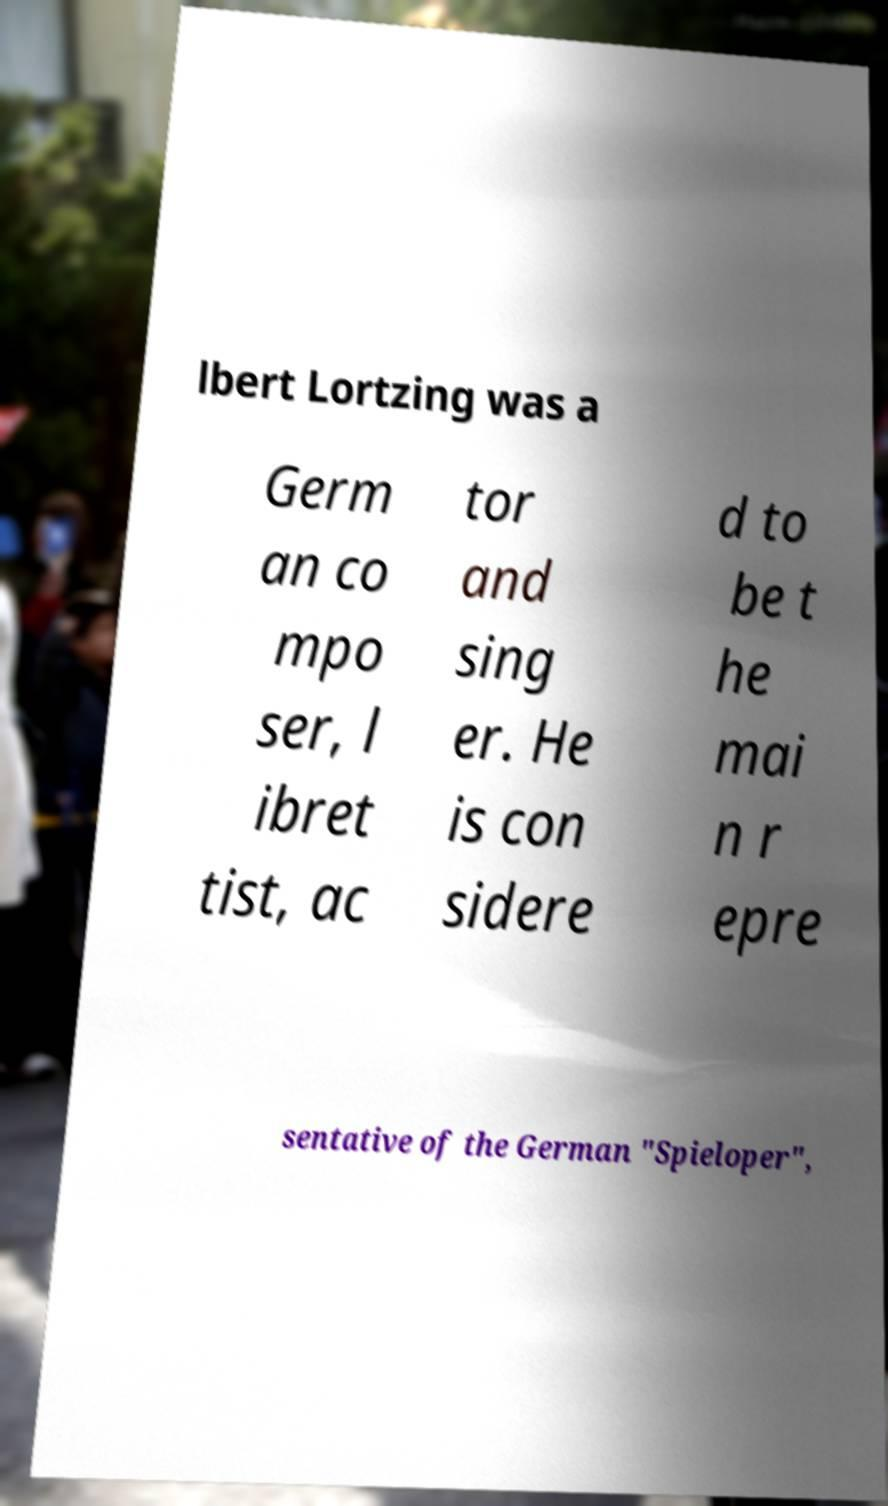For documentation purposes, I need the text within this image transcribed. Could you provide that? lbert Lortzing was a Germ an co mpo ser, l ibret tist, ac tor and sing er. He is con sidere d to be t he mai n r epre sentative of the German "Spieloper", 